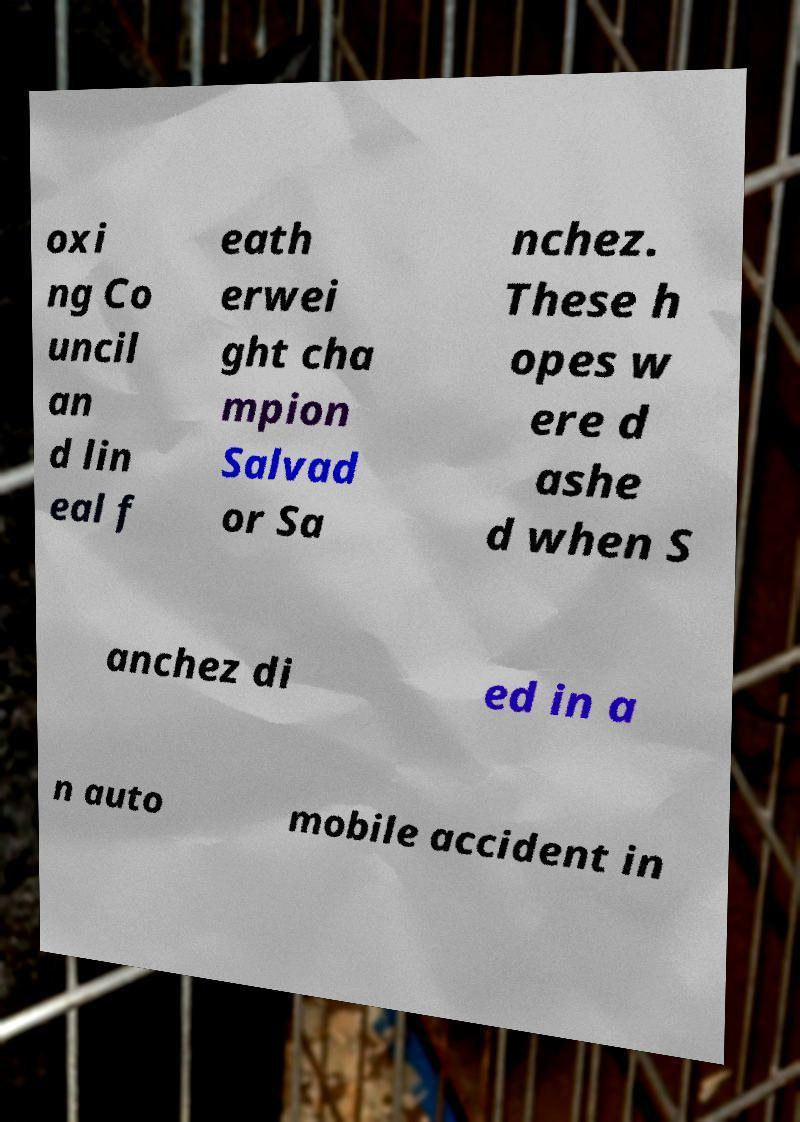Could you assist in decoding the text presented in this image and type it out clearly? oxi ng Co uncil an d lin eal f eath erwei ght cha mpion Salvad or Sa nchez. These h opes w ere d ashe d when S anchez di ed in a n auto mobile accident in 